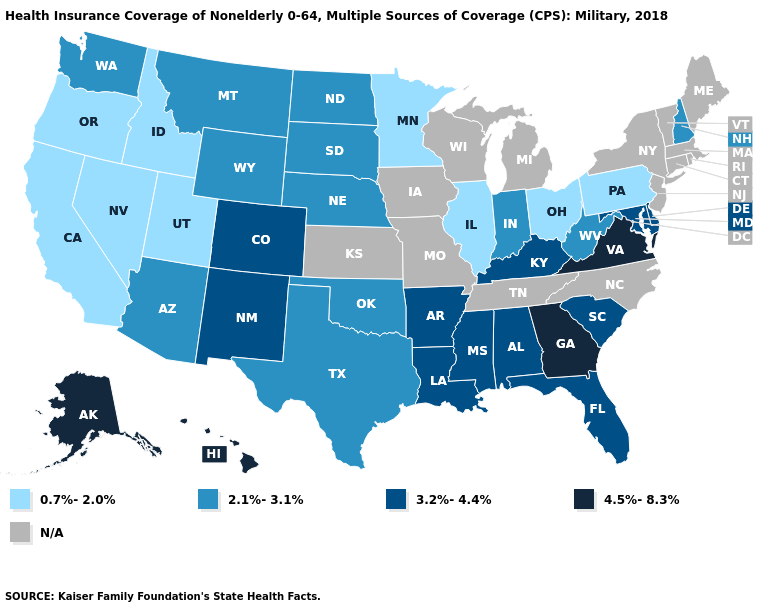Does the map have missing data?
Give a very brief answer. Yes. What is the value of New Hampshire?
Short answer required. 2.1%-3.1%. What is the highest value in the USA?
Short answer required. 4.5%-8.3%. Does Indiana have the highest value in the MidWest?
Write a very short answer. Yes. Name the states that have a value in the range 2.1%-3.1%?
Keep it brief. Arizona, Indiana, Montana, Nebraska, New Hampshire, North Dakota, Oklahoma, South Dakota, Texas, Washington, West Virginia, Wyoming. Name the states that have a value in the range 4.5%-8.3%?
Keep it brief. Alaska, Georgia, Hawaii, Virginia. Among the states that border Colorado , does Nebraska have the lowest value?
Short answer required. No. What is the highest value in the South ?
Write a very short answer. 4.5%-8.3%. Name the states that have a value in the range 2.1%-3.1%?
Write a very short answer. Arizona, Indiana, Montana, Nebraska, New Hampshire, North Dakota, Oklahoma, South Dakota, Texas, Washington, West Virginia, Wyoming. Which states have the lowest value in the USA?
Be succinct. California, Idaho, Illinois, Minnesota, Nevada, Ohio, Oregon, Pennsylvania, Utah. Name the states that have a value in the range N/A?
Keep it brief. Connecticut, Iowa, Kansas, Maine, Massachusetts, Michigan, Missouri, New Jersey, New York, North Carolina, Rhode Island, Tennessee, Vermont, Wisconsin. Which states have the lowest value in the South?
Quick response, please. Oklahoma, Texas, West Virginia. What is the highest value in the Northeast ?
Give a very brief answer. 2.1%-3.1%. Does the first symbol in the legend represent the smallest category?
Answer briefly. Yes. 